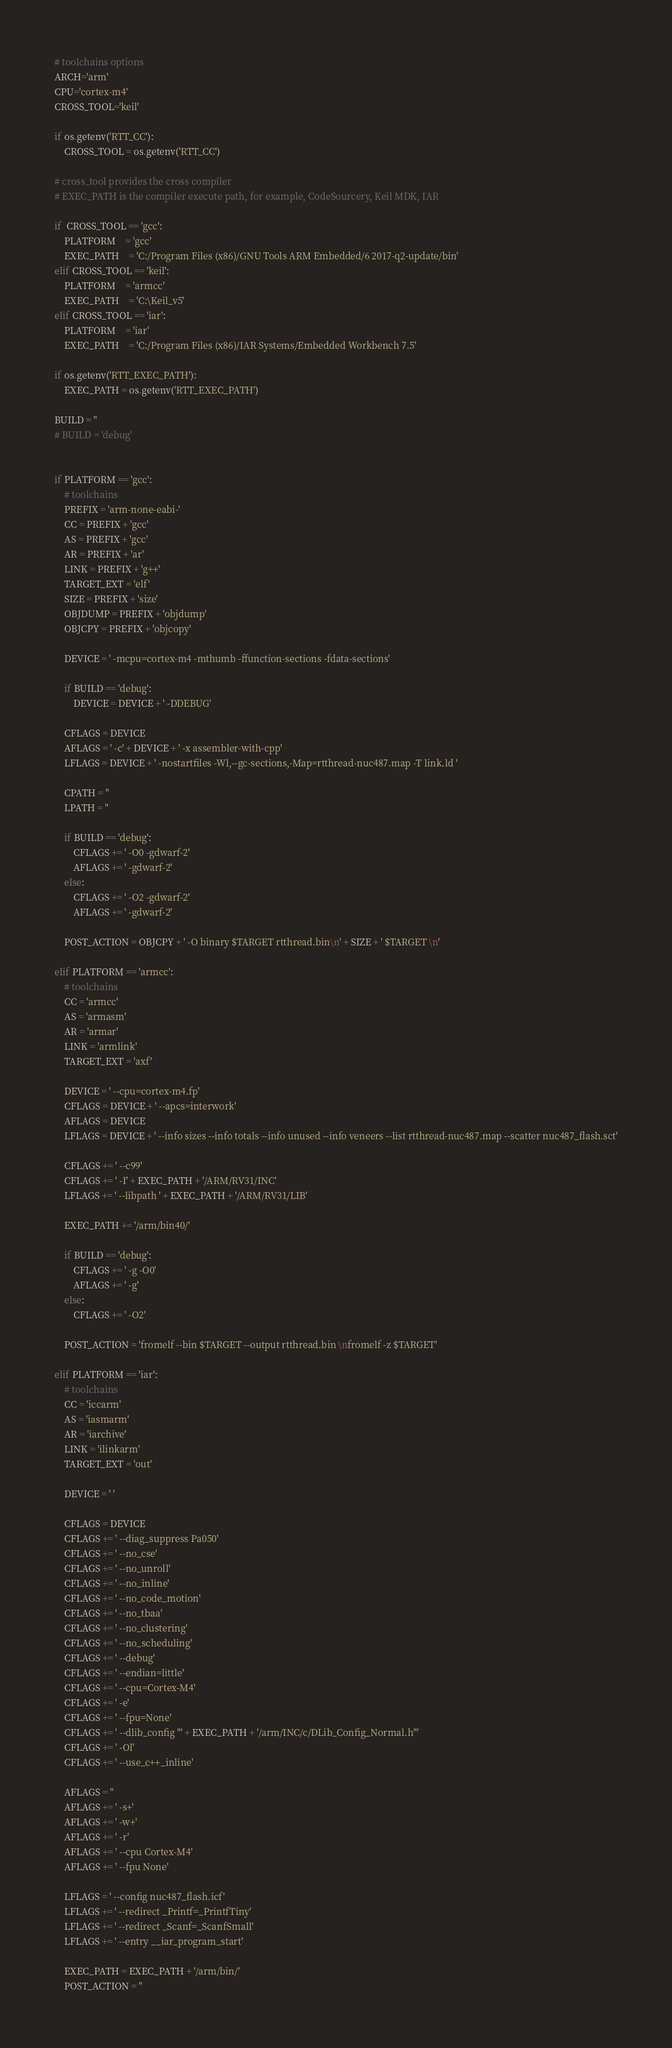Convert code to text. <code><loc_0><loc_0><loc_500><loc_500><_Python_>
# toolchains options
ARCH='arm'
CPU='cortex-m4'
CROSS_TOOL='keil'

if os.getenv('RTT_CC'):
	CROSS_TOOL = os.getenv('RTT_CC')

# cross_tool provides the cross compiler
# EXEC_PATH is the compiler execute path, for example, CodeSourcery, Keil MDK, IAR

if  CROSS_TOOL == 'gcc':
	PLATFORM 	= 'gcc'
	EXEC_PATH 	= 'C:/Program Files (x86)/GNU Tools ARM Embedded/6 2017-q2-update/bin'
elif CROSS_TOOL == 'keil':
	PLATFORM 	= 'armcc'
	EXEC_PATH 	= 'C:\Keil_v5'
elif CROSS_TOOL == 'iar':
	PLATFORM 	= 'iar'
	EXEC_PATH 	= 'C:/Program Files (x86)/IAR Systems/Embedded Workbench 7.5'

if os.getenv('RTT_EXEC_PATH'):
	EXEC_PATH = os.getenv('RTT_EXEC_PATH')

BUILD = ''
# BUILD = 'debug'


if PLATFORM == 'gcc':
    # toolchains
    PREFIX = 'arm-none-eabi-'
    CC = PREFIX + 'gcc'
    AS = PREFIX + 'gcc'
    AR = PREFIX + 'ar'
    LINK = PREFIX + 'g++'
    TARGET_EXT = 'elf'
    SIZE = PREFIX + 'size'
    OBJDUMP = PREFIX + 'objdump'
    OBJCPY = PREFIX + 'objcopy'

    DEVICE = ' -mcpu=cortex-m4 -mthumb -ffunction-sections -fdata-sections'

    if BUILD == 'debug':
        DEVICE = DEVICE + ' -DDEBUG'

    CFLAGS = DEVICE
    AFLAGS = ' -c' + DEVICE + ' -x assembler-with-cpp'
    LFLAGS = DEVICE + ' -nostartfiles -Wl,--gc-sections,-Map=rtthread-nuc487.map -T link.ld '

    CPATH = ''
    LPATH = ''

    if BUILD == 'debug':
        CFLAGS += ' -O0 -gdwarf-2'
        AFLAGS += ' -gdwarf-2'
    else:
        CFLAGS += ' -O2 -gdwarf-2'
        AFLAGS += ' -gdwarf-2'

    POST_ACTION = OBJCPY + ' -O binary $TARGET rtthread.bin\n' + SIZE + ' $TARGET \n'

elif PLATFORM == 'armcc':
    # toolchains
    CC = 'armcc'
    AS = 'armasm'
    AR = 'armar'
    LINK = 'armlink'
    TARGET_EXT = 'axf'

    DEVICE = ' --cpu=cortex-m4.fp'
    CFLAGS = DEVICE + ' --apcs=interwork'
    AFLAGS = DEVICE
    LFLAGS = DEVICE + ' --info sizes --info totals --info unused --info veneers --list rtthread-nuc487.map --scatter nuc487_flash.sct'

    CFLAGS += ' --c99'
    CFLAGS += ' -I' + EXEC_PATH + '/ARM/RV31/INC'
    LFLAGS += ' --libpath ' + EXEC_PATH + '/ARM/RV31/LIB'

    EXEC_PATH += '/arm/bin40/'

    if BUILD == 'debug':
        CFLAGS += ' -g -O0'
        AFLAGS += ' -g'
    else:
        CFLAGS += ' -O2'

    POST_ACTION = 'fromelf --bin $TARGET --output rtthread.bin \nfromelf -z $TARGET'

elif PLATFORM == 'iar':
    # toolchains
    CC = 'iccarm'
    AS = 'iasmarm'
    AR = 'iarchive'
    LINK = 'ilinkarm'
    TARGET_EXT = 'out'

    DEVICE = ' '

    CFLAGS = DEVICE
    CFLAGS += ' --diag_suppress Pa050'
    CFLAGS += ' --no_cse' 
    CFLAGS += ' --no_unroll' 
    CFLAGS += ' --no_inline' 
    CFLAGS += ' --no_code_motion' 
    CFLAGS += ' --no_tbaa' 
    CFLAGS += ' --no_clustering' 
    CFLAGS += ' --no_scheduling' 
    CFLAGS += ' --debug' 
    CFLAGS += ' --endian=little' 
    CFLAGS += ' --cpu=Cortex-M4' 
    CFLAGS += ' -e' 
    CFLAGS += ' --fpu=None'
    CFLAGS += ' --dlib_config "' + EXEC_PATH + '/arm/INC/c/DLib_Config_Normal.h"'    
    CFLAGS += ' -Ol'    
    CFLAGS += ' --use_c++_inline'
        
    AFLAGS = ''
    AFLAGS += ' -s+' 
    AFLAGS += ' -w+' 
    AFLAGS += ' -r' 
    AFLAGS += ' --cpu Cortex-M4' 
    AFLAGS += ' --fpu None' 

    LFLAGS = ' --config nuc487_flash.icf'
    LFLAGS += ' --redirect _Printf=_PrintfTiny' 
    LFLAGS += ' --redirect _Scanf=_ScanfSmall' 
    LFLAGS += ' --entry __iar_program_start'    

    EXEC_PATH = EXEC_PATH + '/arm/bin/'
    POST_ACTION = ''
</code> 